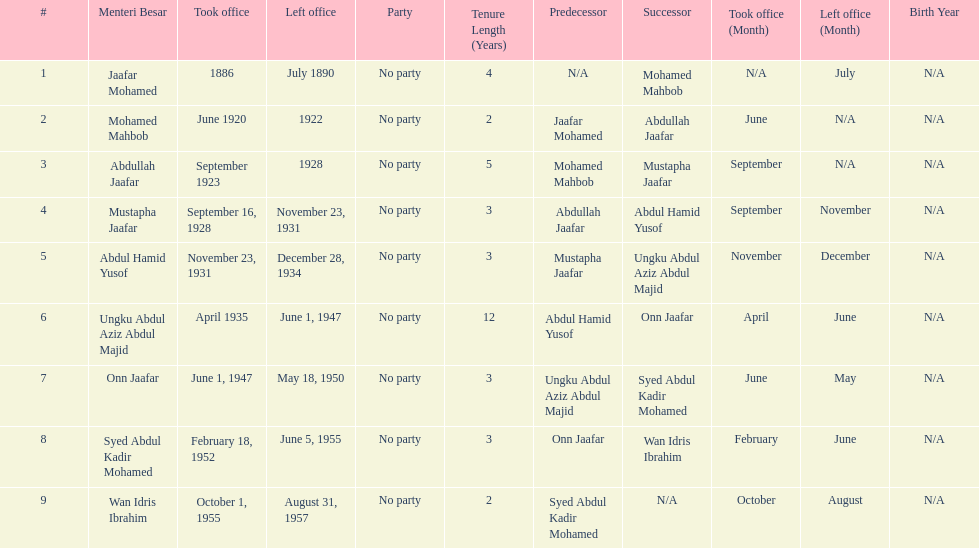Who was in office after mustapha jaafar Abdul Hamid Yusof. 